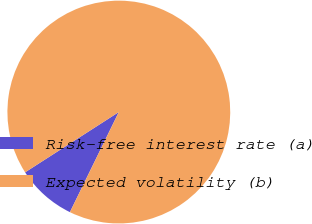Convert chart to OTSL. <chart><loc_0><loc_0><loc_500><loc_500><pie_chart><fcel>Risk-free interest rate (a)<fcel>Expected volatility (b)<nl><fcel>8.67%<fcel>91.33%<nl></chart> 